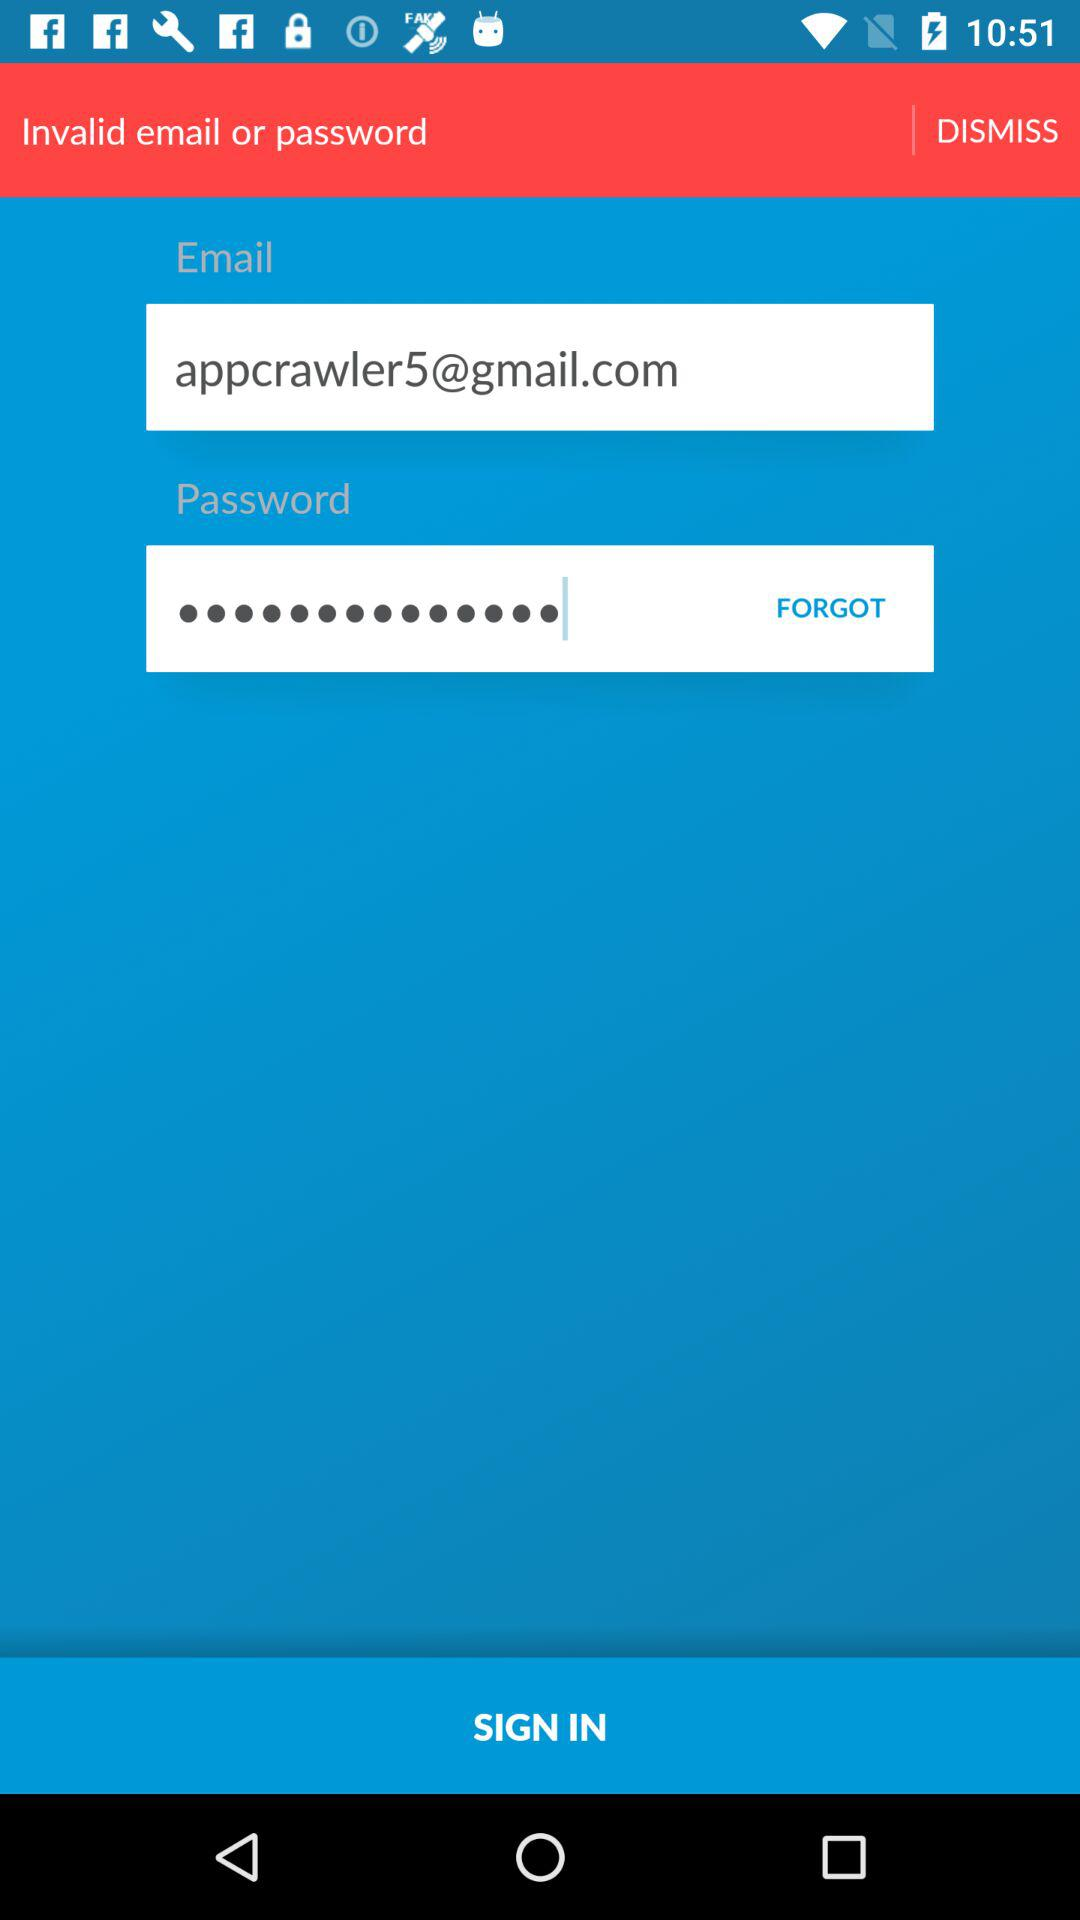What is the email address? The email address is appcrawler5@gmail.com. 